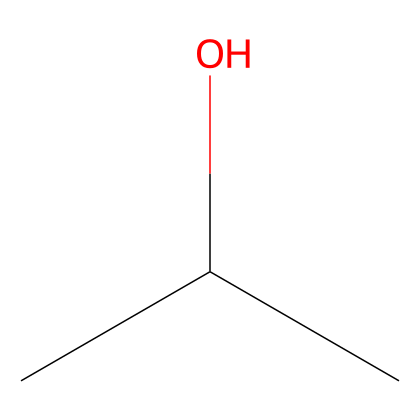What is the name of this chemical? The SMILES notation "CC(C)O" corresponds to isopropyl alcohol, which is commonly known as rubbing alcohol. The structure features a hydroxyl group (OH) attached to a branched carbon chain.
Answer: isopropyl alcohol How many carbon atoms are in isopropyl alcohol? In the SMILES representation "CC(C)O," there are three 'C' symbols, which indicate three carbon atoms in the molecular structure. Each 'C' corresponds to a carbon atom.
Answer: three What functional group is present in isopropyl alcohol? The structure includes a hydroxyl group (-OH) as indicated by the presence of the "O" at the end of the SMILES notation. This functional group defines the compound as an alcohol.
Answer: hydroxyl group How many hydrogen atoms are bonded to the carbon skeleton of isopropyl alcohol? In isopropyl alcohol, based on the carbon structure (three carbons), it can be deduced that there are a total of eight hydrogen atoms considering each carbon atom can bond with enough hydrogens to satisfy their tetravalency.
Answer: eight What type of solvent is isopropyl alcohol classified as? Given its chemical structure containing a hydroxyl group, isopropyl alcohol is classified as a polar solvent, which is effective in dissolving both polar and nonpolar substances.
Answer: polar solvent Why is isopropyl alcohol preferred for cleaning electronics? Isopropyl alcohol has a high evaporation rate due to its low boiling point, and its non-conductive nature allows it to safely clean electronic components without leaving moisture or conductive residues behind.
Answer: high evaporation rate Is isopropyl alcohol biodegradable? While isopropyl alcohol can break down in the environment, it is not considered highly biodegradable since it can persist depending on environmental conditions.
Answer: not highly biodegradable 